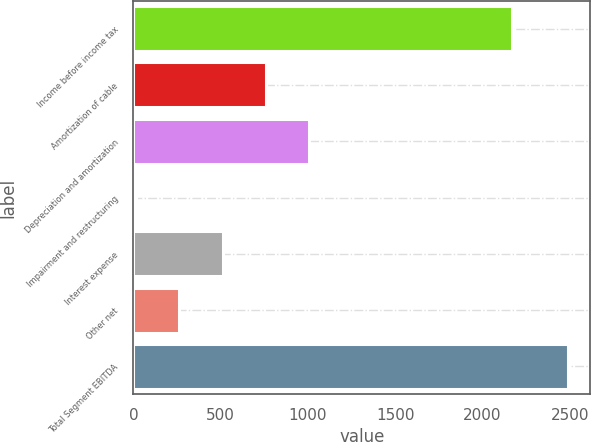<chart> <loc_0><loc_0><loc_500><loc_500><bar_chart><fcel>Income before income tax<fcel>Amortization of cable<fcel>Depreciation and amortization<fcel>Impairment and restructuring<fcel>Interest expense<fcel>Other net<fcel>Total Segment EBITDA<nl><fcel>2170<fcel>758.8<fcel>1006.4<fcel>16<fcel>511.2<fcel>263.6<fcel>2492<nl></chart> 